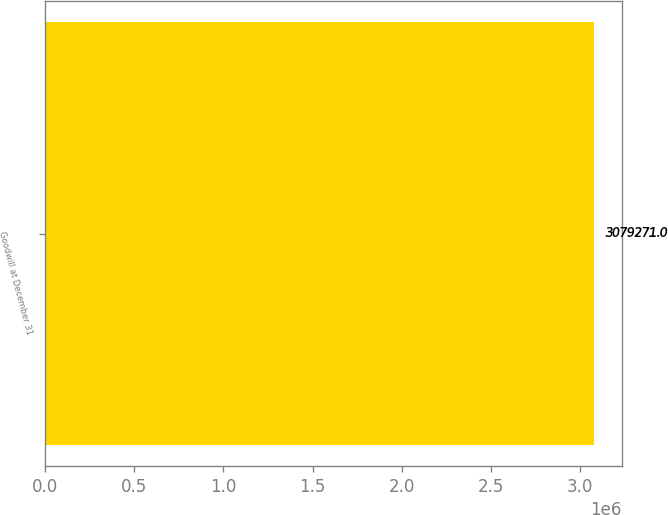<chart> <loc_0><loc_0><loc_500><loc_500><bar_chart><fcel>Goodwill at December 31<nl><fcel>3.07927e+06<nl></chart> 